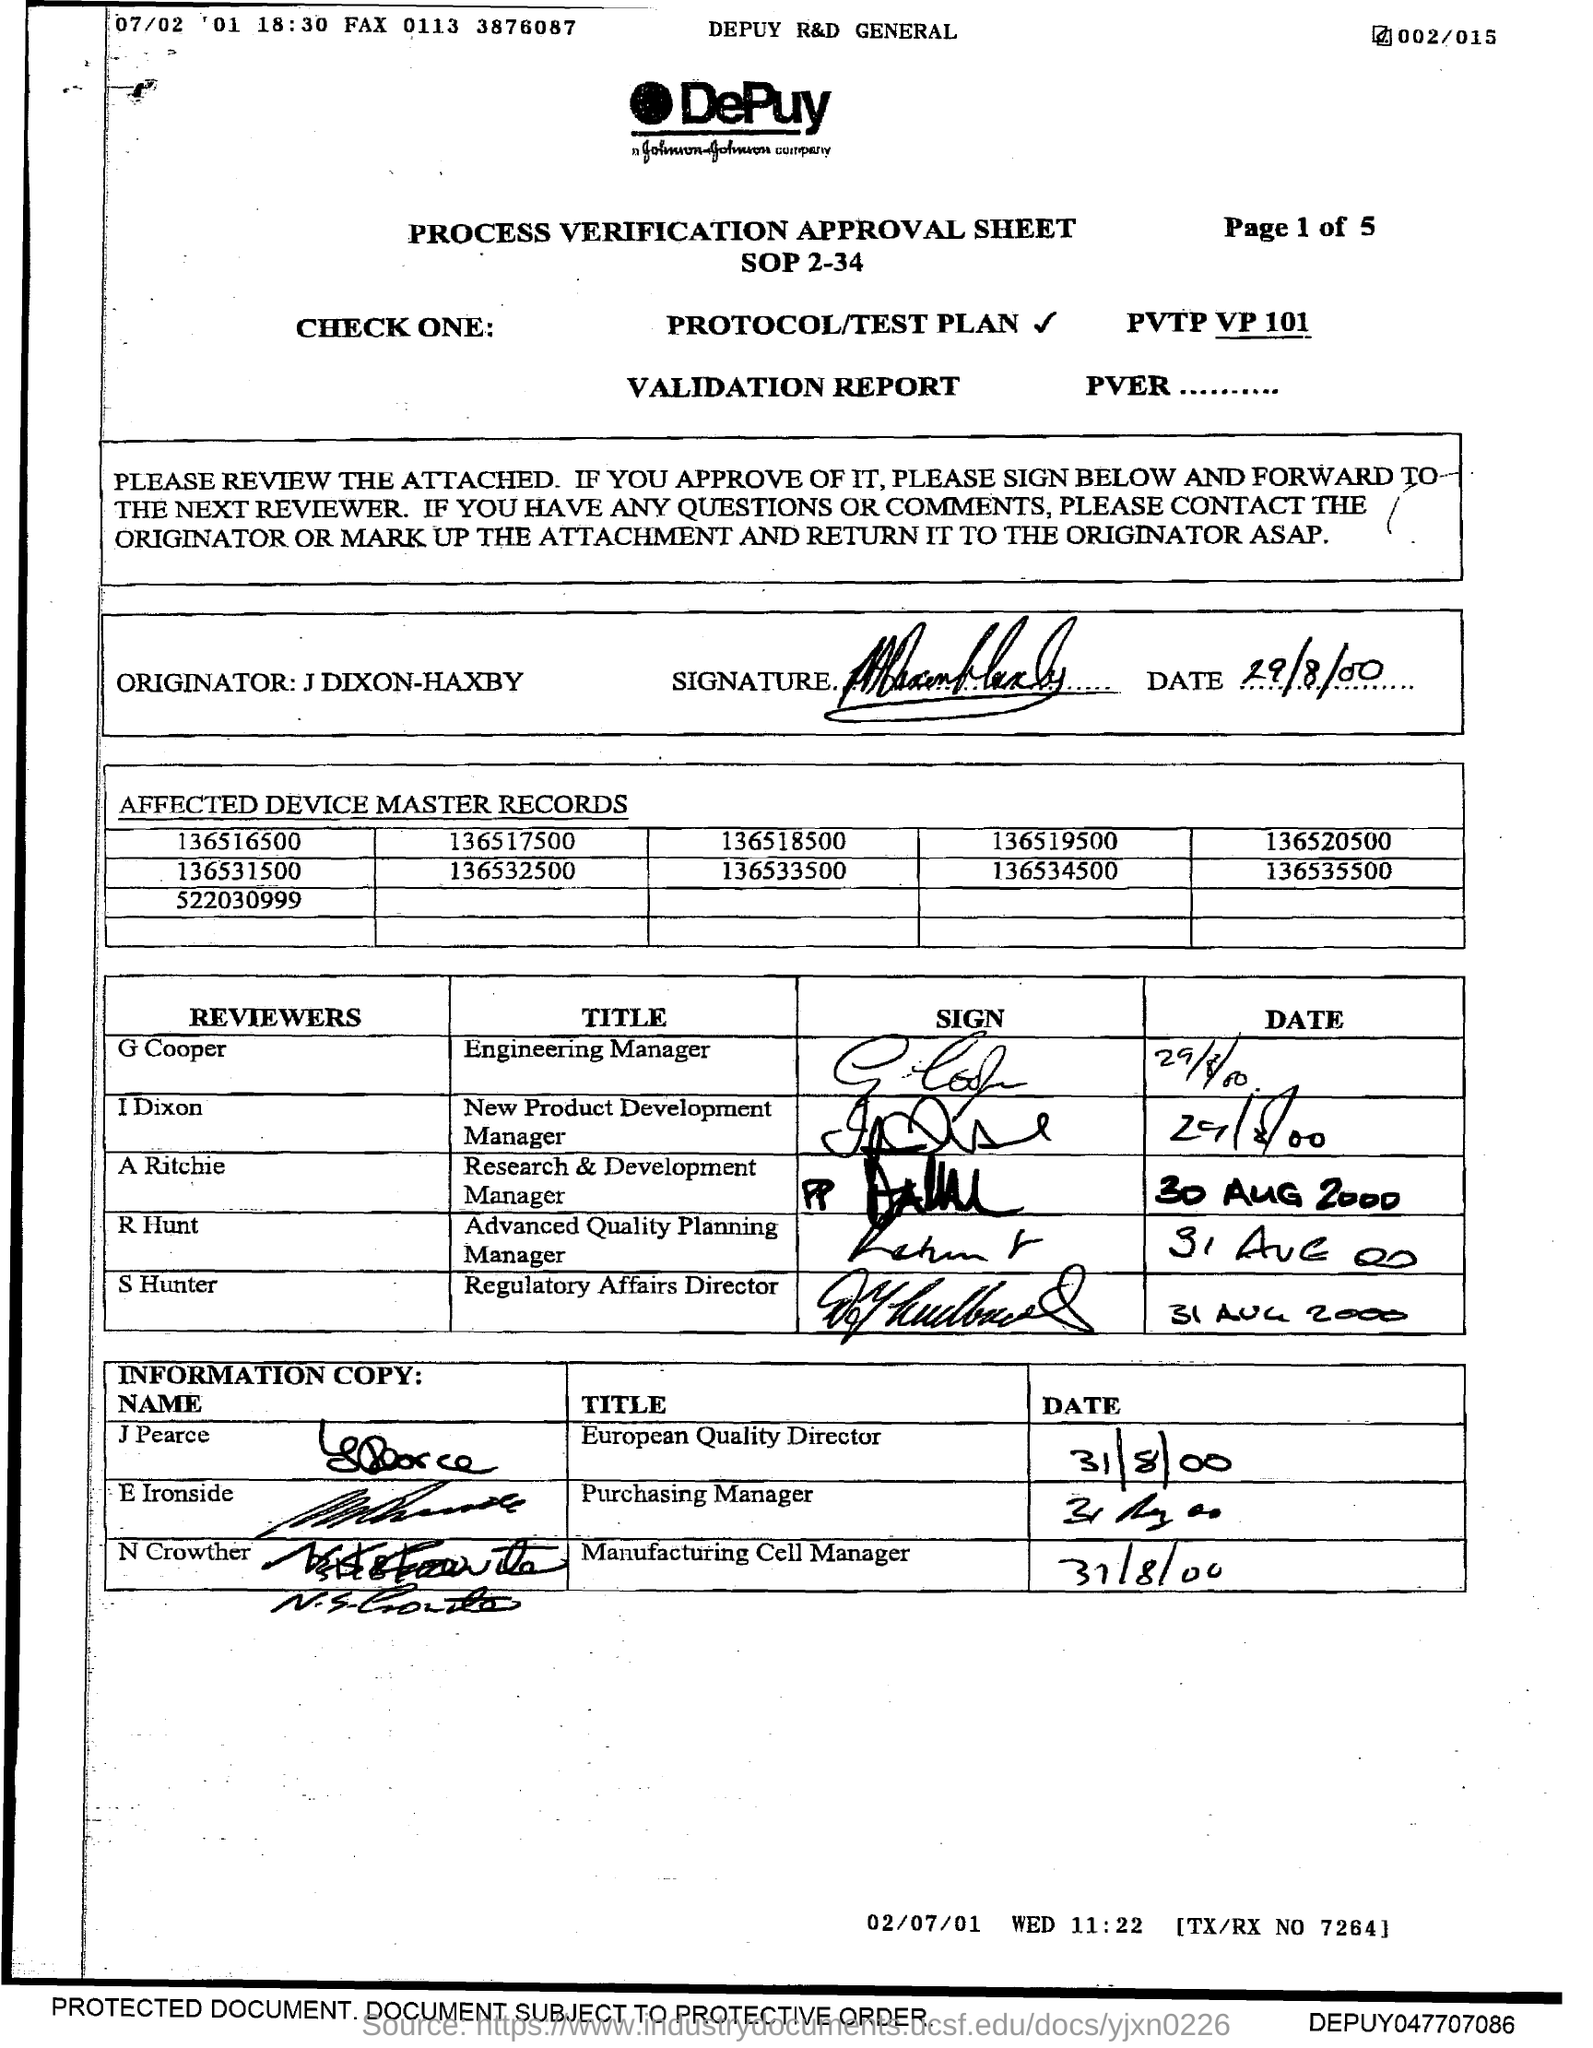The title Engineering Manager is Reviewed by?
Offer a very short reply. G Cooper. Which title is reviewed by R Hunt?
Offer a very short reply. Advanced Quality Planning Manager. The title Regulatory Affairs Director is Reviewed by?
Your answer should be compact. S Hunter. 